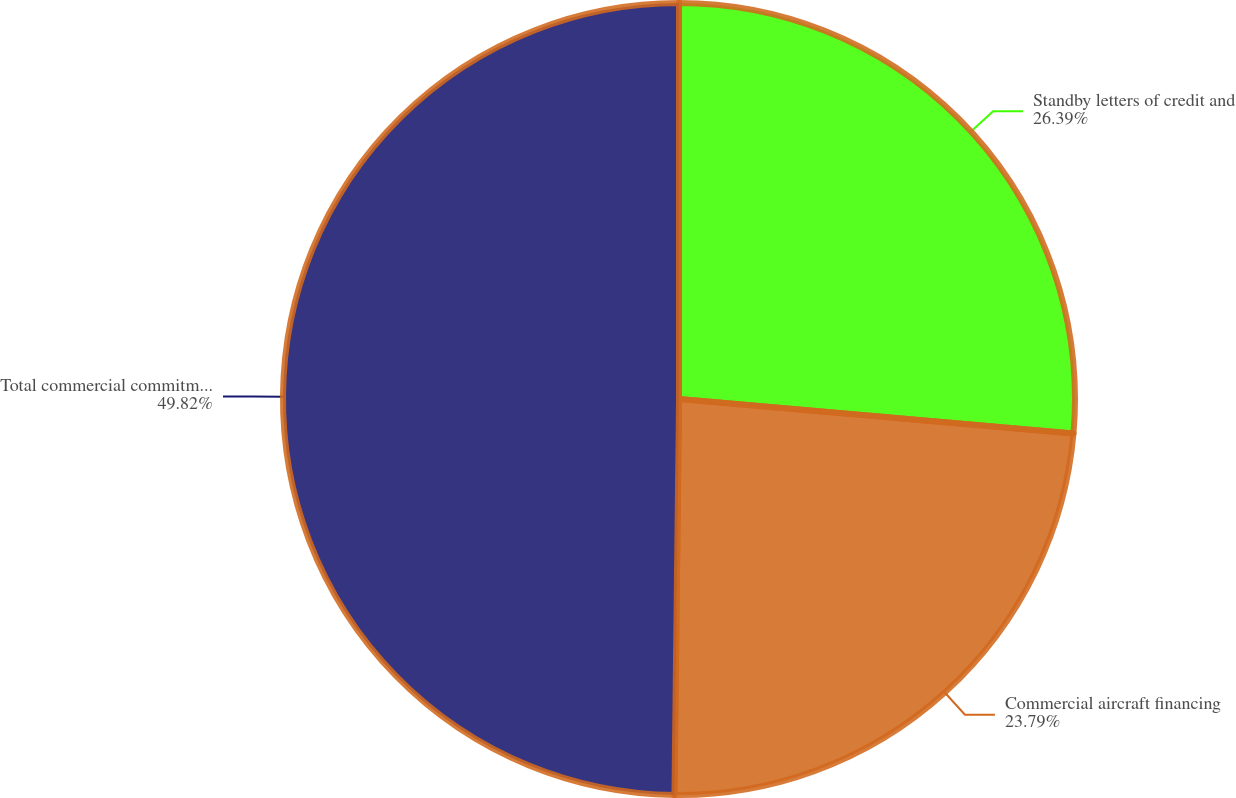Convert chart to OTSL. <chart><loc_0><loc_0><loc_500><loc_500><pie_chart><fcel>Standby letters of credit and<fcel>Commercial aircraft financing<fcel>Total commercial commitments<nl><fcel>26.39%<fcel>23.79%<fcel>49.81%<nl></chart> 